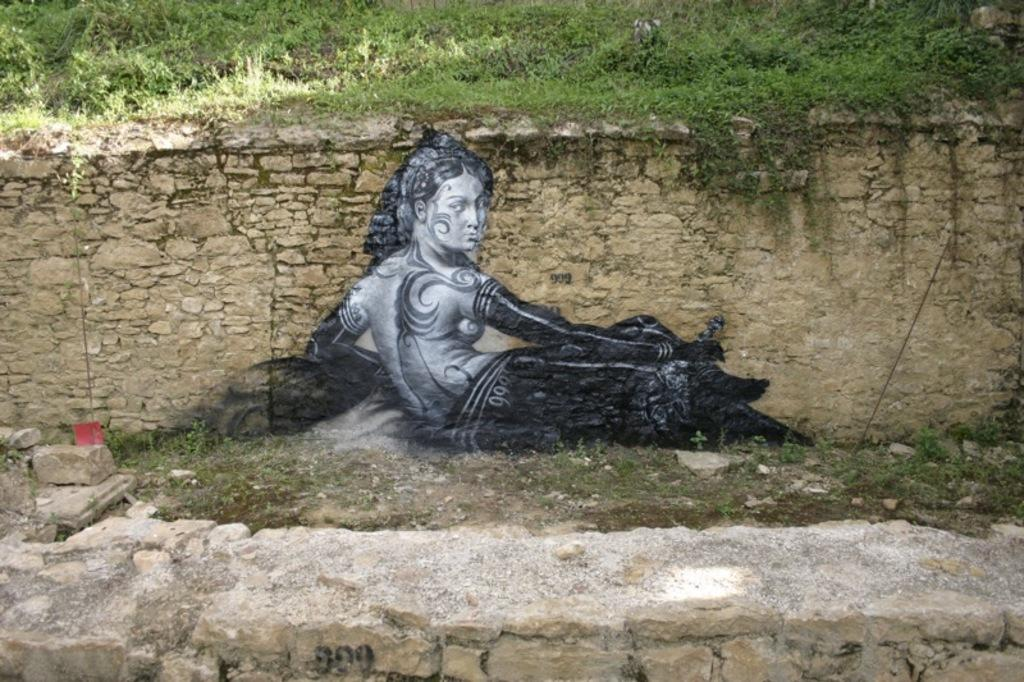What is depicted on the wall in the image? There is a painting of a woman on a wall in the image. What type of natural elements can be seen in the image? There are stones and grass visible in the image. Where is the desk located in the image? There is no desk present in the image. What type of bell can be heard in the image? There is no bell present in the image, and therefore no sound can be heard. 